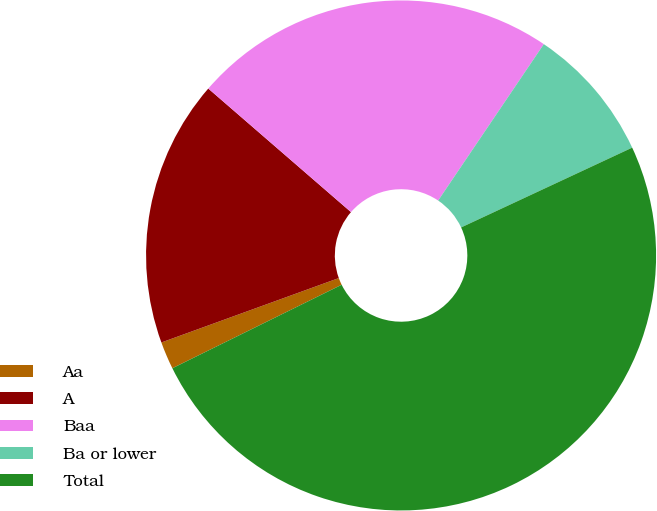Convert chart. <chart><loc_0><loc_0><loc_500><loc_500><pie_chart><fcel>Aa<fcel>A<fcel>Baa<fcel>Ba or lower<fcel>Total<nl><fcel>1.75%<fcel>16.9%<fcel>23.1%<fcel>8.6%<fcel>49.66%<nl></chart> 